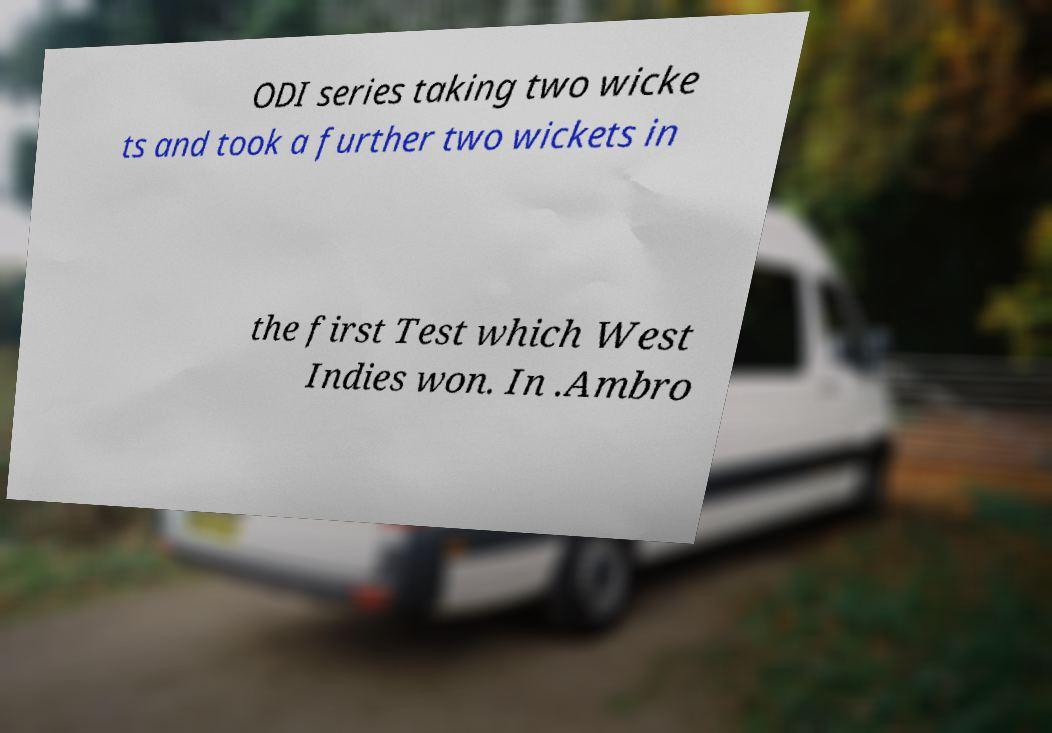There's text embedded in this image that I need extracted. Can you transcribe it verbatim? ODI series taking two wicke ts and took a further two wickets in the first Test which West Indies won. In .Ambro 